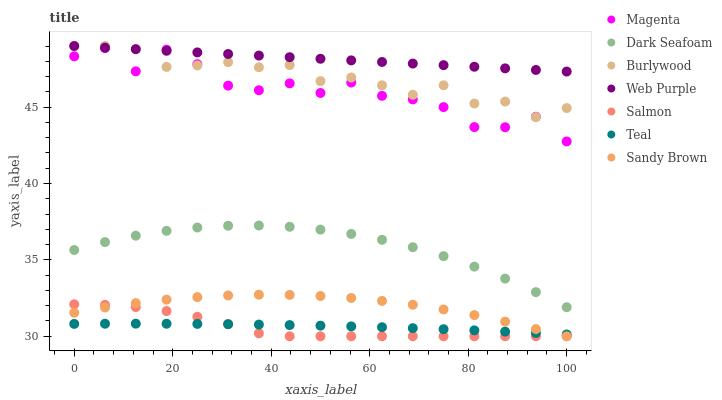Does Salmon have the minimum area under the curve?
Answer yes or no. Yes. Does Web Purple have the maximum area under the curve?
Answer yes or no. Yes. Does Dark Seafoam have the minimum area under the curve?
Answer yes or no. No. Does Dark Seafoam have the maximum area under the curve?
Answer yes or no. No. Is Web Purple the smoothest?
Answer yes or no. Yes. Is Magenta the roughest?
Answer yes or no. Yes. Is Salmon the smoothest?
Answer yes or no. No. Is Salmon the roughest?
Answer yes or no. No. Does Salmon have the lowest value?
Answer yes or no. Yes. Does Dark Seafoam have the lowest value?
Answer yes or no. No. Does Web Purple have the highest value?
Answer yes or no. Yes. Does Salmon have the highest value?
Answer yes or no. No. Is Sandy Brown less than Web Purple?
Answer yes or no. Yes. Is Burlywood greater than Teal?
Answer yes or no. Yes. Does Sandy Brown intersect Teal?
Answer yes or no. Yes. Is Sandy Brown less than Teal?
Answer yes or no. No. Is Sandy Brown greater than Teal?
Answer yes or no. No. Does Sandy Brown intersect Web Purple?
Answer yes or no. No. 